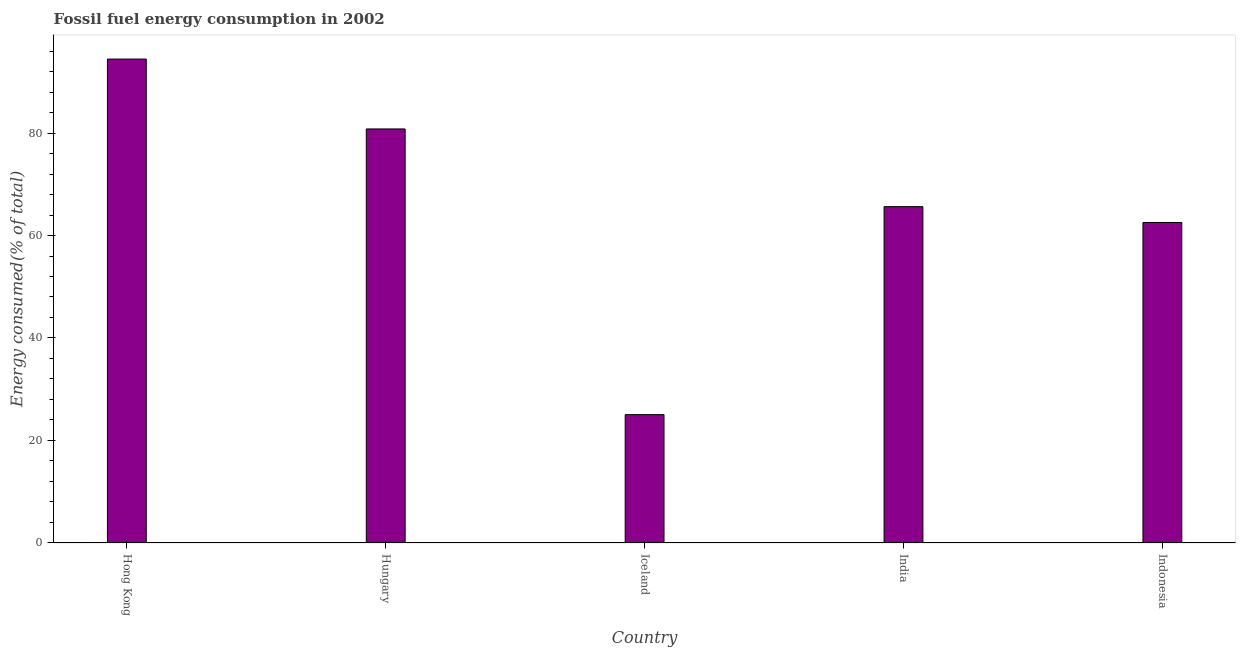Does the graph contain any zero values?
Ensure brevity in your answer.  No. Does the graph contain grids?
Offer a terse response. No. What is the title of the graph?
Offer a terse response. Fossil fuel energy consumption in 2002. What is the label or title of the X-axis?
Your response must be concise. Country. What is the label or title of the Y-axis?
Make the answer very short. Energy consumed(% of total). What is the fossil fuel energy consumption in Hungary?
Provide a succinct answer. 80.79. Across all countries, what is the maximum fossil fuel energy consumption?
Ensure brevity in your answer.  94.43. Across all countries, what is the minimum fossil fuel energy consumption?
Offer a very short reply. 25.05. In which country was the fossil fuel energy consumption maximum?
Give a very brief answer. Hong Kong. What is the sum of the fossil fuel energy consumption?
Your response must be concise. 328.44. What is the difference between the fossil fuel energy consumption in India and Indonesia?
Your response must be concise. 3.09. What is the average fossil fuel energy consumption per country?
Your answer should be compact. 65.69. What is the median fossil fuel energy consumption?
Offer a very short reply. 65.63. In how many countries, is the fossil fuel energy consumption greater than 12 %?
Offer a terse response. 5. What is the ratio of the fossil fuel energy consumption in Hong Kong to that in Indonesia?
Ensure brevity in your answer.  1.51. What is the difference between the highest and the second highest fossil fuel energy consumption?
Provide a succinct answer. 13.63. Is the sum of the fossil fuel energy consumption in India and Indonesia greater than the maximum fossil fuel energy consumption across all countries?
Provide a succinct answer. Yes. What is the difference between the highest and the lowest fossil fuel energy consumption?
Provide a short and direct response. 69.38. In how many countries, is the fossil fuel energy consumption greater than the average fossil fuel energy consumption taken over all countries?
Your response must be concise. 2. How many bars are there?
Provide a short and direct response. 5. Are all the bars in the graph horizontal?
Provide a succinct answer. No. How many countries are there in the graph?
Your answer should be very brief. 5. What is the Energy consumed(% of total) of Hong Kong?
Keep it short and to the point. 94.43. What is the Energy consumed(% of total) of Hungary?
Your answer should be compact. 80.79. What is the Energy consumed(% of total) in Iceland?
Provide a short and direct response. 25.05. What is the Energy consumed(% of total) in India?
Make the answer very short. 65.63. What is the Energy consumed(% of total) of Indonesia?
Your answer should be compact. 62.54. What is the difference between the Energy consumed(% of total) in Hong Kong and Hungary?
Ensure brevity in your answer.  13.64. What is the difference between the Energy consumed(% of total) in Hong Kong and Iceland?
Offer a very short reply. 69.38. What is the difference between the Energy consumed(% of total) in Hong Kong and India?
Your response must be concise. 28.8. What is the difference between the Energy consumed(% of total) in Hong Kong and Indonesia?
Your answer should be very brief. 31.88. What is the difference between the Energy consumed(% of total) in Hungary and Iceland?
Offer a terse response. 55.75. What is the difference between the Energy consumed(% of total) in Hungary and India?
Your response must be concise. 15.16. What is the difference between the Energy consumed(% of total) in Hungary and Indonesia?
Your answer should be compact. 18.25. What is the difference between the Energy consumed(% of total) in Iceland and India?
Your response must be concise. -40.58. What is the difference between the Energy consumed(% of total) in Iceland and Indonesia?
Provide a short and direct response. -37.5. What is the difference between the Energy consumed(% of total) in India and Indonesia?
Your answer should be very brief. 3.09. What is the ratio of the Energy consumed(% of total) in Hong Kong to that in Hungary?
Keep it short and to the point. 1.17. What is the ratio of the Energy consumed(% of total) in Hong Kong to that in Iceland?
Make the answer very short. 3.77. What is the ratio of the Energy consumed(% of total) in Hong Kong to that in India?
Your answer should be compact. 1.44. What is the ratio of the Energy consumed(% of total) in Hong Kong to that in Indonesia?
Make the answer very short. 1.51. What is the ratio of the Energy consumed(% of total) in Hungary to that in Iceland?
Your answer should be compact. 3.23. What is the ratio of the Energy consumed(% of total) in Hungary to that in India?
Offer a terse response. 1.23. What is the ratio of the Energy consumed(% of total) in Hungary to that in Indonesia?
Offer a very short reply. 1.29. What is the ratio of the Energy consumed(% of total) in Iceland to that in India?
Offer a very short reply. 0.38. What is the ratio of the Energy consumed(% of total) in India to that in Indonesia?
Offer a very short reply. 1.05. 